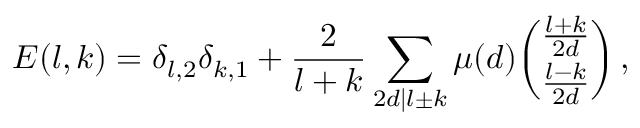<formula> <loc_0><loc_0><loc_500><loc_500>E ( l , k ) = \delta _ { l , 2 } \delta _ { k , 1 } + \frac { 2 } { l + k } \sum _ { 2 d | l \pm k } \mu ( d ) { \binom { \frac { l + k } { 2 d } } { \frac { l - k } { 2 d } } } \, ,</formula> 